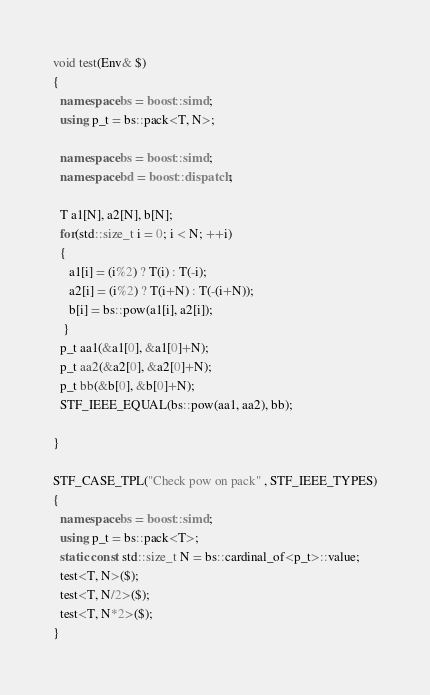<code> <loc_0><loc_0><loc_500><loc_500><_C++_>void test(Env& $)
{
  namespace bs = boost::simd;
  using p_t = bs::pack<T, N>;

  namespace bs = boost::simd;
  namespace bd = boost::dispatch;

  T a1[N], a2[N], b[N];
  for(std::size_t i = 0; i < N; ++i)
  {
     a1[i] = (i%2) ? T(i) : T(-i);
     a2[i] = (i%2) ? T(i+N) : T(-(i+N));
     b[i] = bs::pow(a1[i], a2[i]);
   }
  p_t aa1(&a1[0], &a1[0]+N);
  p_t aa2(&a2[0], &a2[0]+N);
  p_t bb(&b[0], &b[0]+N);
  STF_IEEE_EQUAL(bs::pow(aa1, aa2), bb);

}

STF_CASE_TPL("Check pow on pack" , STF_IEEE_TYPES)
{
  namespace bs = boost::simd;
  using p_t = bs::pack<T>;
  static const std::size_t N = bs::cardinal_of<p_t>::value;
  test<T, N>($);
  test<T, N/2>($);
  test<T, N*2>($);
}
</code> 